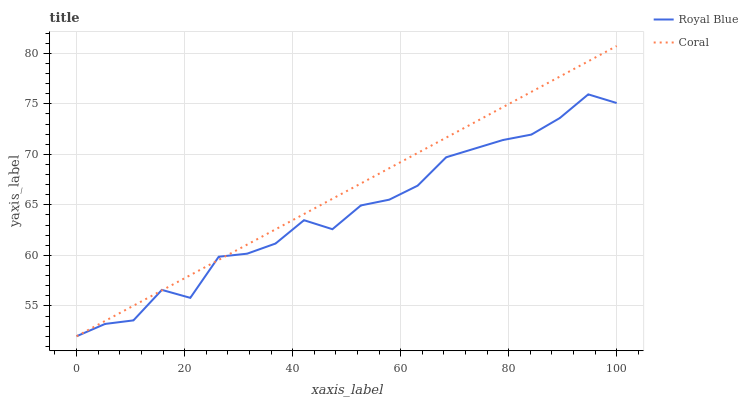Does Royal Blue have the minimum area under the curve?
Answer yes or no. Yes. Does Coral have the maximum area under the curve?
Answer yes or no. Yes. Does Coral have the minimum area under the curve?
Answer yes or no. No. Is Coral the smoothest?
Answer yes or no. Yes. Is Royal Blue the roughest?
Answer yes or no. Yes. Is Coral the roughest?
Answer yes or no. No. Does Royal Blue have the lowest value?
Answer yes or no. Yes. Does Coral have the highest value?
Answer yes or no. Yes. Does Coral intersect Royal Blue?
Answer yes or no. Yes. Is Coral less than Royal Blue?
Answer yes or no. No. Is Coral greater than Royal Blue?
Answer yes or no. No. 